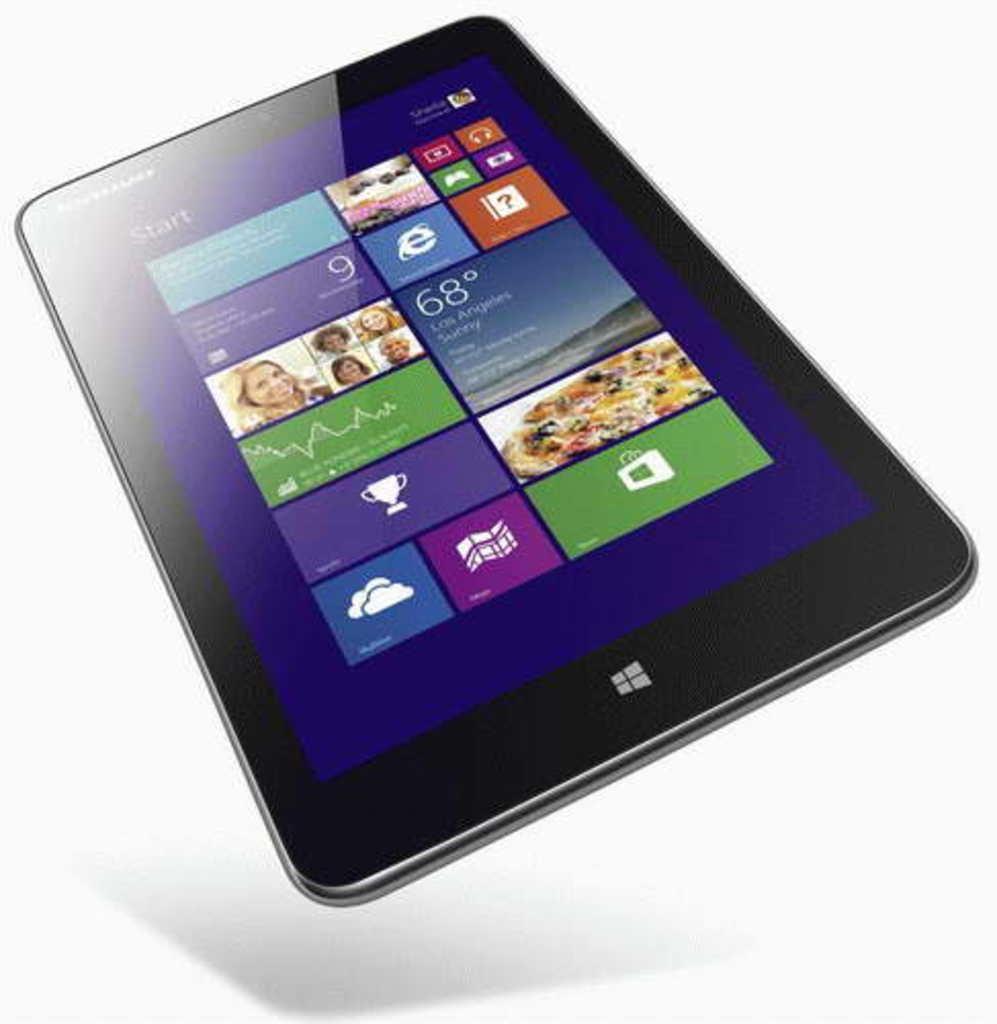Could you give a brief overview of what you see in this image? In this image we can see a tablet and we can see some pictures of people and there is some text and there are some other things on the display. The background is white in color. 